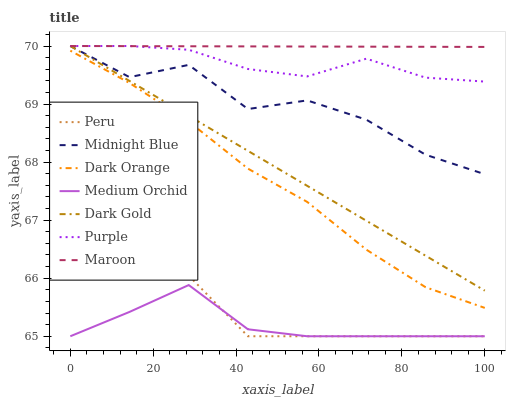Does Medium Orchid have the minimum area under the curve?
Answer yes or no. Yes. Does Maroon have the maximum area under the curve?
Answer yes or no. Yes. Does Midnight Blue have the minimum area under the curve?
Answer yes or no. No. Does Midnight Blue have the maximum area under the curve?
Answer yes or no. No. Is Maroon the smoothest?
Answer yes or no. Yes. Is Midnight Blue the roughest?
Answer yes or no. Yes. Is Dark Gold the smoothest?
Answer yes or no. No. Is Dark Gold the roughest?
Answer yes or no. No. Does Midnight Blue have the lowest value?
Answer yes or no. No. Does Maroon have the highest value?
Answer yes or no. Yes. Does Medium Orchid have the highest value?
Answer yes or no. No. Is Medium Orchid less than Purple?
Answer yes or no. Yes. Is Midnight Blue greater than Dark Orange?
Answer yes or no. Yes. Does Medium Orchid intersect Purple?
Answer yes or no. No. 